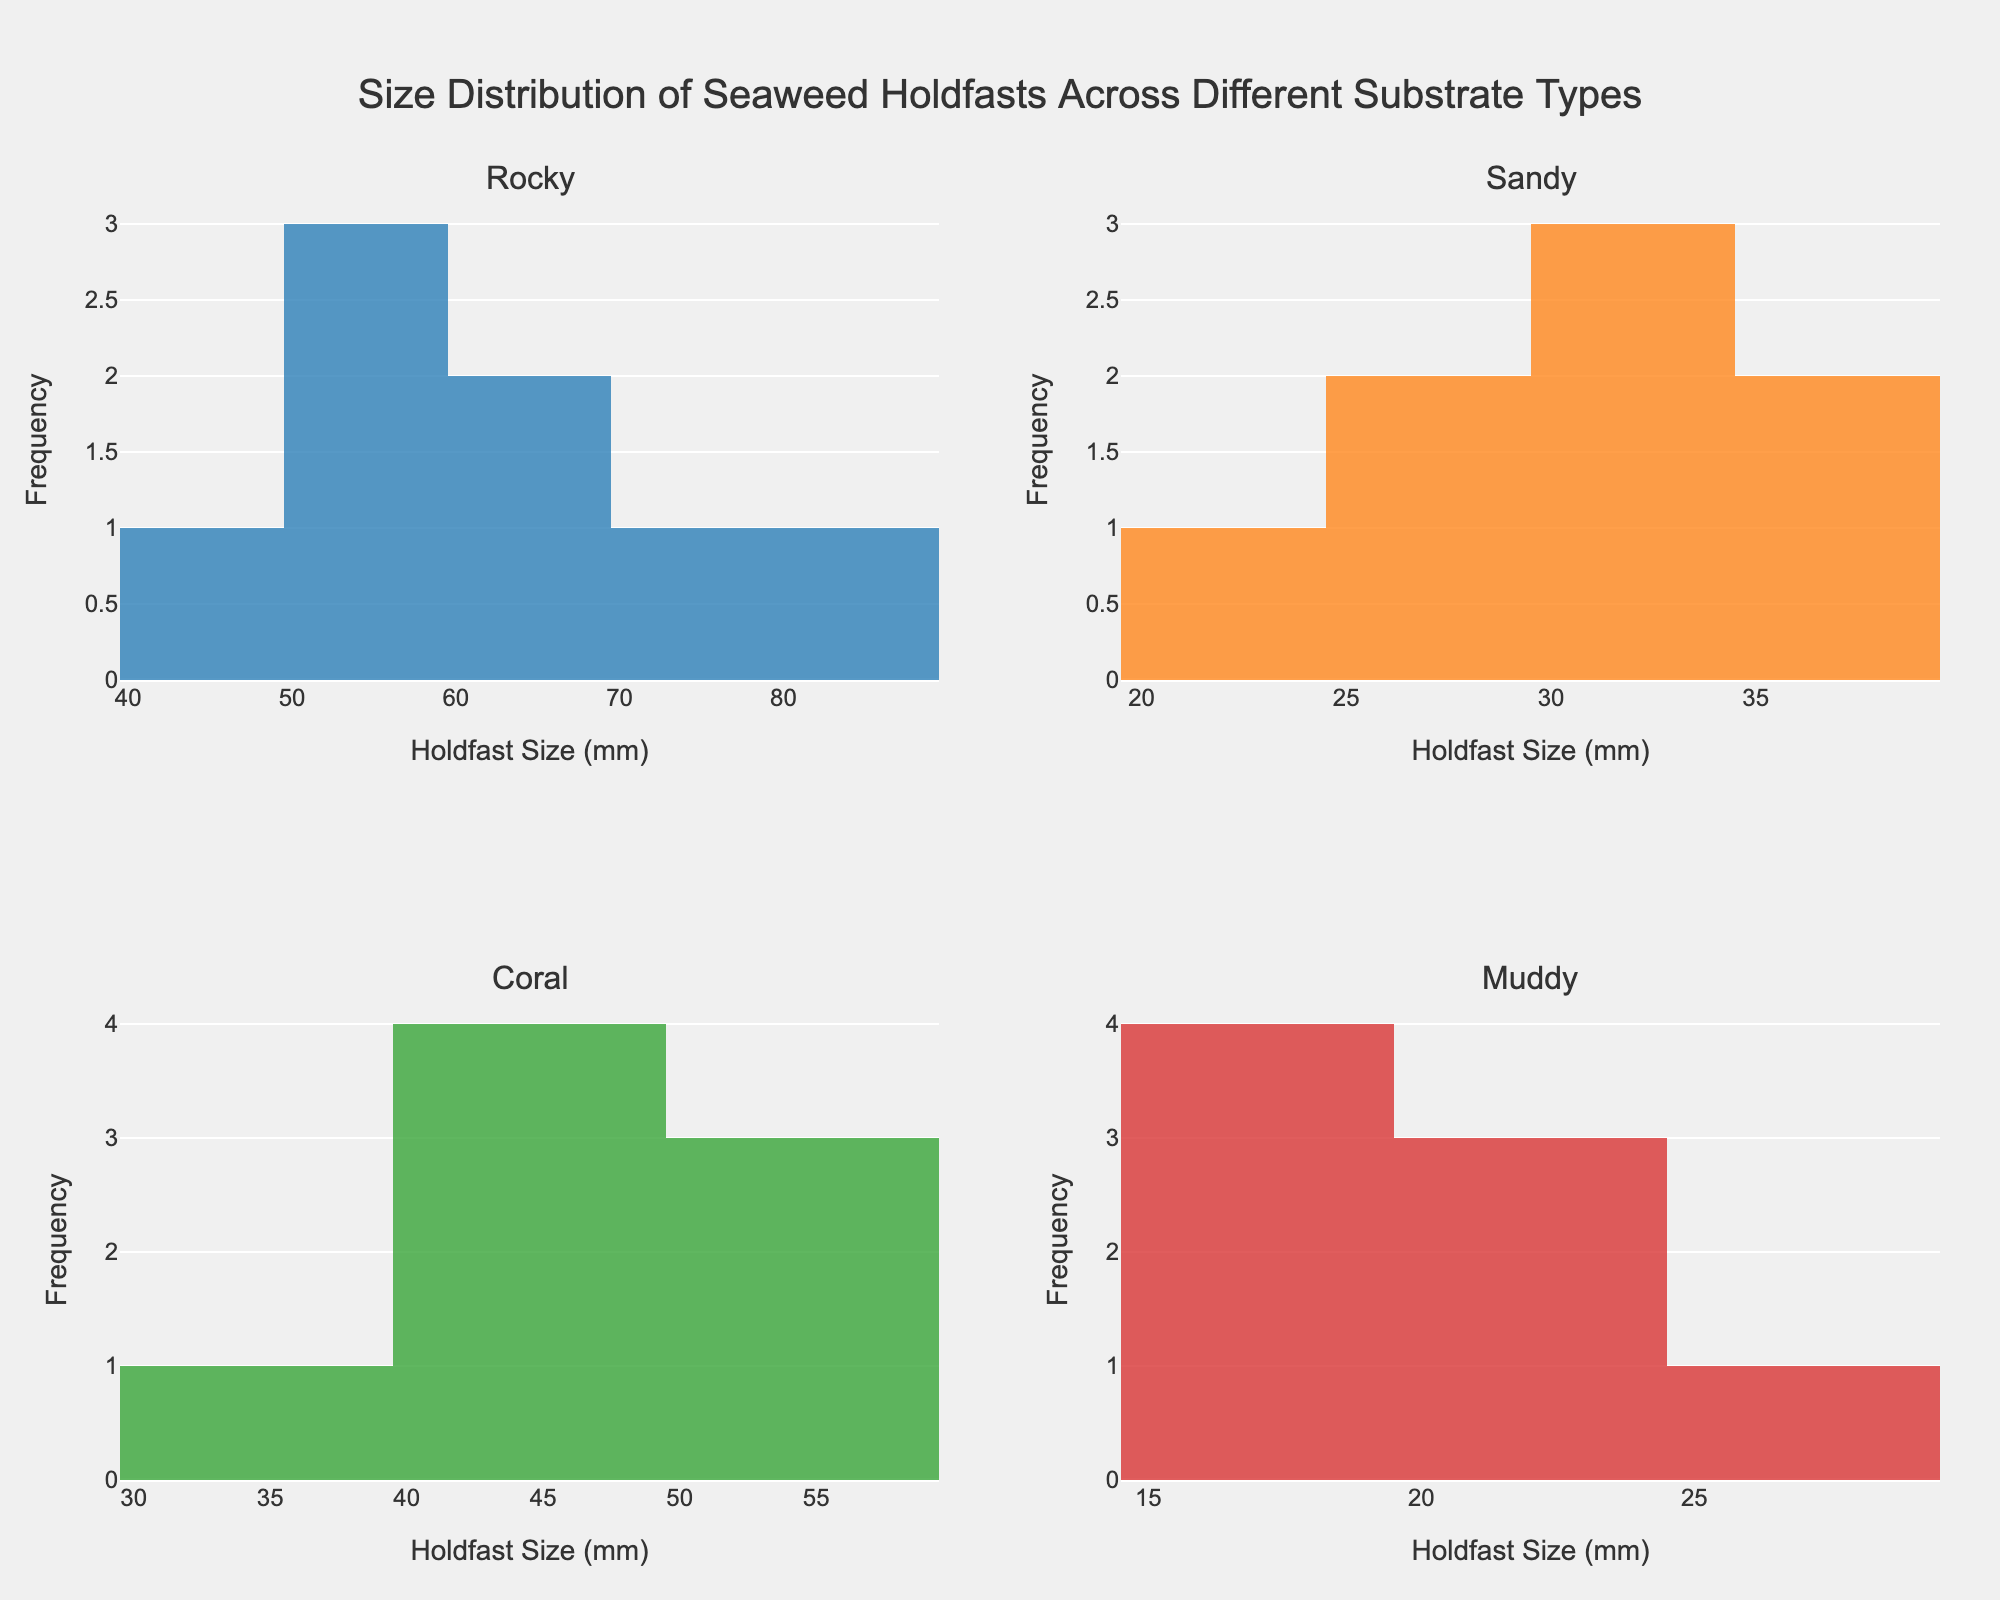What's the title of the figure? The title of the figure is clearly shown at the top. It reads "Size Distribution of Seaweed Holdfasts Across Different Substrate Types".
Answer: Size Distribution of Seaweed Holdfasts Across Different Substrate Types How many subplots are displayed in the figure? There are four individual histograms, each representing a different substrate type: Rocky, Sandy, Coral, and Muddy.
Answer: Four What is the range of holdfast sizes for the Rocky substrate? In the Rocky subplot, the smallest holdfast size appears to be 45 mm, and the largest holdfast size is around 80 mm.
Answer: 45 to 80 mm Which substrate type has the smallest holdfast sizes? By inspecting the minima across all subplots, the Muddy substrate has the smallest holdfast sizes, ranging from 15 mm to 26 mm.
Answer: Muddy Which substrate type has the most varied holdfast size distribution? The Rocky substrate displays the most varied distribution with holdfast sizes spreading broadly from 45 mm to 80 mm.
Answer: Rocky On which substrate type does the mode of holdfast size appear to be around 25 mm? The histogram for the Muddy substrate shows the most frequent holdfast size (mode) around the 25 mm mark.
Answer: Muddy What is the most common holdfast size range for Sandy substrates? Sandy substrates have a histogram peak indicating that the most common holdfast size ranges from 25 mm to 35 mm.
Answer: 25 to 35 mm Compare the holdfast size distribution between Rocky and Coral substrates. Which one has a larger average size? By inspecting the distributions, the Rocky substrate shows holdfast sizes consistently larger and more varied than those in the Coral substrate, indicating a higher average size in Rocky.
Answer: Rocky Which substrate type has the smallest maximum holdfast size? The histogram for the Muddy substrate shows that its largest holdfast size is around 26 mm, which is the smallest maximum size among all substrates.
Answer: Muddy Do any substrates show a roughly normal distribution in holdfast sizes? The Coral substrate's histogram appears to show a roughly normal distribution in holdfast sizes, centering around 45-50 mm.
Answer: Coral 